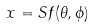Convert formula to latex. <formula><loc_0><loc_0><loc_500><loc_500>x = S f ( \theta , \phi )</formula> 